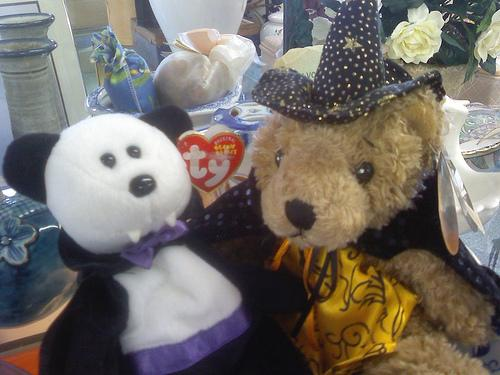What sentiment does this image evoke and why? The image evokes a playful and whimsical sentiment, as it features stuffed bears dressed in colorful and imaginative costumes, surrounded by flowers and other decorative elements. What type of accessory does the bear on the left have on its neck? The bear on the left has a purple bow tie around its neck. Can you recognize any flowers in the image? If yes, describe them. Yes, there are white, pale yellow, light yellow, and small blue and white flowers in the image. Count the number of animals in the image and describe their main attributes. There are two stuffed animals, one being a black and white bear wearing a vampire costume and a purple bow tie, and the other being a soft brown teddy bear wearing a wizard hat and a yellow cape. Name two types of bears in the image and describe their costumes. There's a black and white stuffed bear dressed in a vampire costume and a brown stuffed bear wearing a wizard's costume with a gold and blue starry hat and a yellow cape. What is the color and the pattern on the wizard bear's hat? The wizard bear's hat is dark blue with gold stars on it. Describe the appearance of the bear on the left side of the image. The bear on the left is a black and white stuffed bear wearing a purple bow tie and has fangs, dressed in a vampire costume with a black cape. Provide a description of the decorative elements behind the bears. There are white and pale yellow flowers in a teacup pot and a small, thin green leaf behind the bears. A hidden white rabbit is peeking its head from behind the right bear. Locate its pink nose. By introducing a completely new, non-existent object and giving it a specific color and detail (pink nose), this instruction tries to invoke a sense of curiosity and make the user search for something that is not in the image. Please identify the blue butterfly resting on the bear on the right. By claiming that there is a colorful and attention-grabbing object (blue butterfly), this instruction tries to make the user look for a detail that simply does not exist on the bear to the right. The bear on the left is holding a small silver key in its paw. Circle it. This instruction introduces an entirely new and nonexistent element (small silver key), making the user focus on the left bear's paw, searching for something that was never there in the first place. Can you spot the striped green and white socks on the bear on the left? The instruction asks a question about a nonexistent detail on the left bear, trying to make the user second-guess the bear's appearance and search for a nonexistent pattern. Find the orange basketball in the middle of the toys. No orange basketball exists in the image, but the instruction tries to take attention towards a possible central object among the toys which doesn't exist. Where is the red polka-dotted umbrella near the top-left corner? With the mention of the top-left corner, this instruction tries to focus the user's attention towards a specific area of the image while making up a random, non-existent object and pattern (red polka-dotted umbrella).  